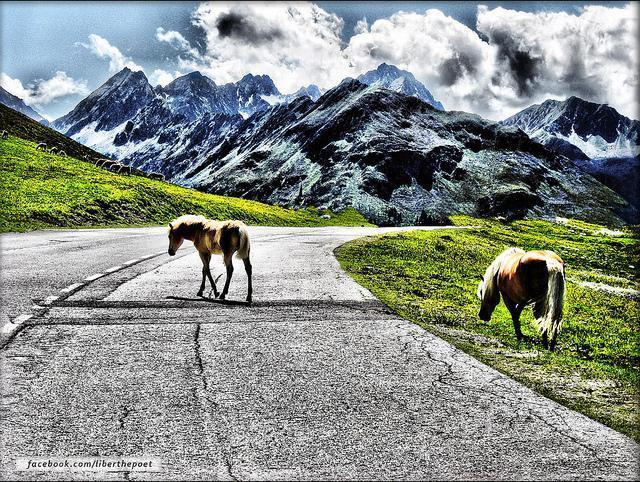How many horses are there?
Give a very brief answer. 2. 